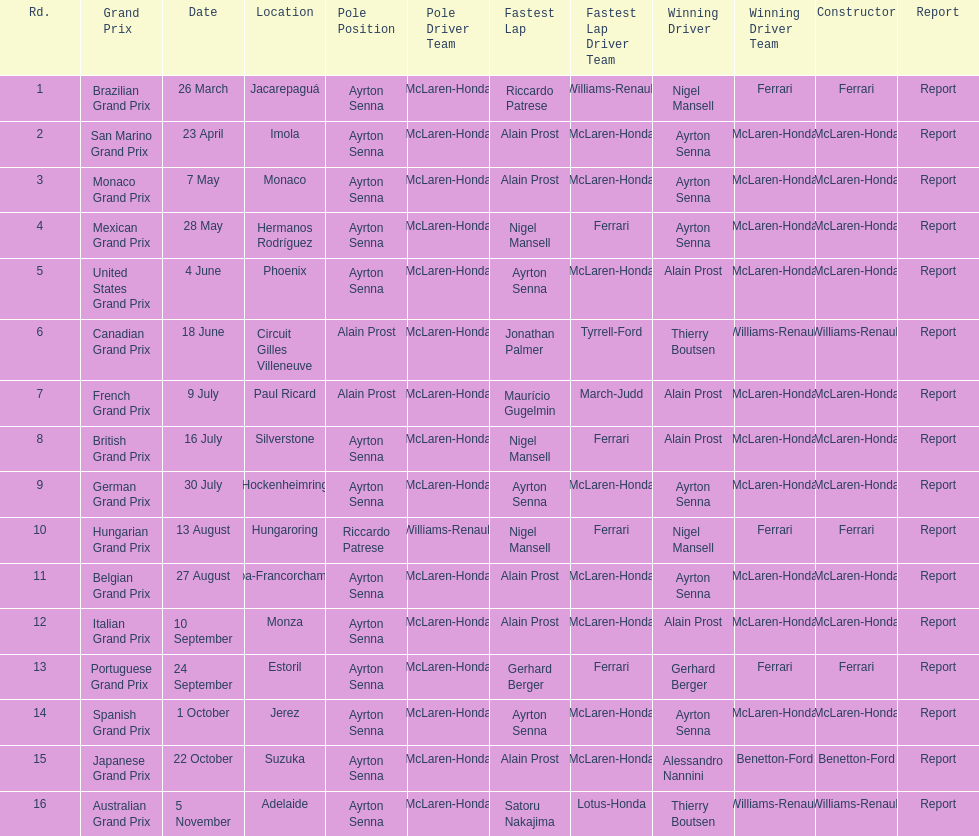Who had the fastest lap at the german grand prix? Ayrton Senna. 